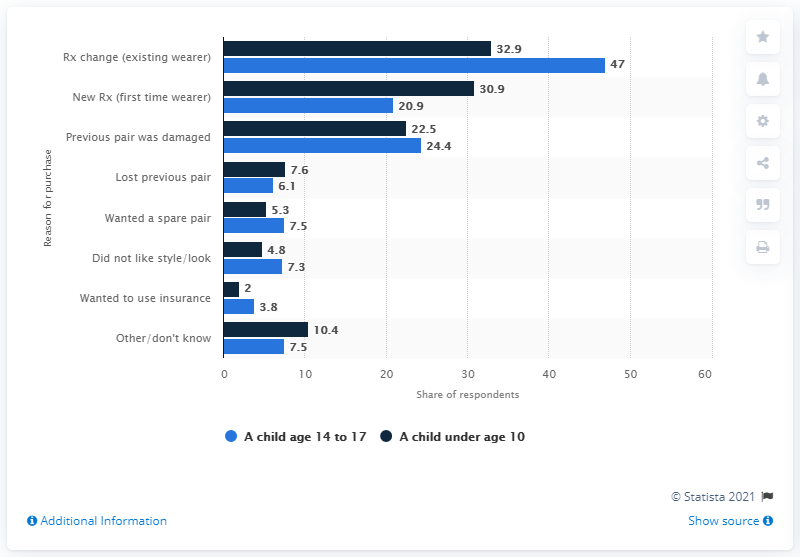List a handful of essential elements in this visual. According to the data, 7.5% of parents purchased the most recent pair of eyeglasses their children have because they wanted a spare pair. 